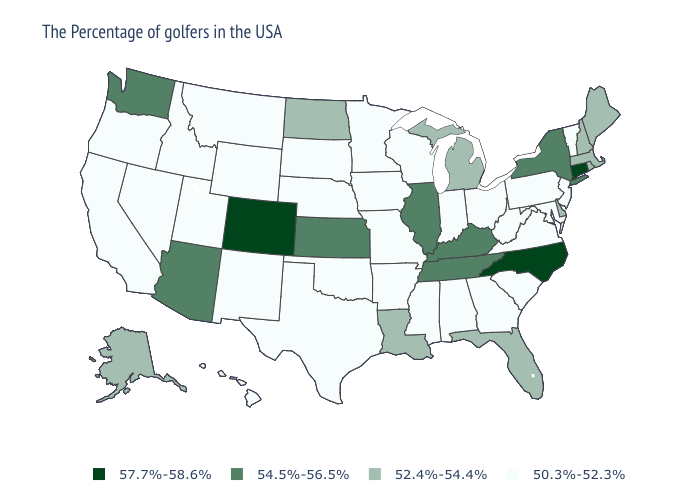How many symbols are there in the legend?
Write a very short answer. 4. Does Hawaii have the same value as Texas?
Give a very brief answer. Yes. Does Arizona have the lowest value in the USA?
Give a very brief answer. No. Which states have the lowest value in the Northeast?
Be succinct. Vermont, New Jersey, Pennsylvania. Name the states that have a value in the range 54.5%-56.5%?
Keep it brief. New York, Kentucky, Tennessee, Illinois, Kansas, Arizona, Washington. What is the value of New Mexico?
Give a very brief answer. 50.3%-52.3%. Name the states that have a value in the range 54.5%-56.5%?
Give a very brief answer. New York, Kentucky, Tennessee, Illinois, Kansas, Arizona, Washington. What is the value of Virginia?
Quick response, please. 50.3%-52.3%. Which states have the highest value in the USA?
Keep it brief. Connecticut, North Carolina, Colorado. Name the states that have a value in the range 52.4%-54.4%?
Quick response, please. Maine, Massachusetts, Rhode Island, New Hampshire, Delaware, Florida, Michigan, Louisiana, North Dakota, Alaska. Among the states that border Iowa , which have the highest value?
Give a very brief answer. Illinois. Name the states that have a value in the range 50.3%-52.3%?
Short answer required. Vermont, New Jersey, Maryland, Pennsylvania, Virginia, South Carolina, West Virginia, Ohio, Georgia, Indiana, Alabama, Wisconsin, Mississippi, Missouri, Arkansas, Minnesota, Iowa, Nebraska, Oklahoma, Texas, South Dakota, Wyoming, New Mexico, Utah, Montana, Idaho, Nevada, California, Oregon, Hawaii. What is the value of Virginia?
Give a very brief answer. 50.3%-52.3%. Which states have the lowest value in the USA?
Short answer required. Vermont, New Jersey, Maryland, Pennsylvania, Virginia, South Carolina, West Virginia, Ohio, Georgia, Indiana, Alabama, Wisconsin, Mississippi, Missouri, Arkansas, Minnesota, Iowa, Nebraska, Oklahoma, Texas, South Dakota, Wyoming, New Mexico, Utah, Montana, Idaho, Nevada, California, Oregon, Hawaii. What is the highest value in states that border Colorado?
Concise answer only. 54.5%-56.5%. 